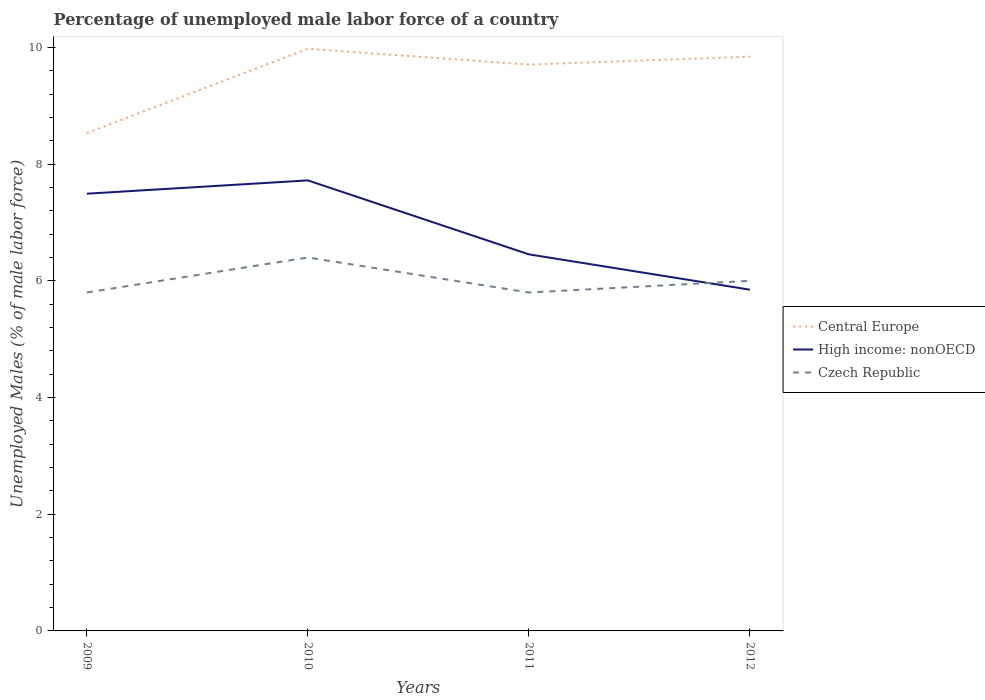Across all years, what is the maximum percentage of unemployed male labor force in Czech Republic?
Keep it short and to the point. 5.8. In which year was the percentage of unemployed male labor force in Czech Republic maximum?
Give a very brief answer. 2009. What is the total percentage of unemployed male labor force in Czech Republic in the graph?
Your answer should be compact. -0.2. What is the difference between the highest and the second highest percentage of unemployed male labor force in Czech Republic?
Provide a short and direct response. 0.6. What is the difference between the highest and the lowest percentage of unemployed male labor force in Central Europe?
Your response must be concise. 3. How many lines are there?
Your answer should be compact. 3. What is the difference between two consecutive major ticks on the Y-axis?
Your answer should be very brief. 2. Are the values on the major ticks of Y-axis written in scientific E-notation?
Ensure brevity in your answer.  No. Does the graph contain any zero values?
Ensure brevity in your answer.  No. What is the title of the graph?
Provide a short and direct response. Percentage of unemployed male labor force of a country. Does "Low income" appear as one of the legend labels in the graph?
Provide a short and direct response. No. What is the label or title of the X-axis?
Your answer should be compact. Years. What is the label or title of the Y-axis?
Provide a succinct answer. Unemployed Males (% of male labor force). What is the Unemployed Males (% of male labor force) in Central Europe in 2009?
Your answer should be compact. 8.53. What is the Unemployed Males (% of male labor force) of High income: nonOECD in 2009?
Your answer should be very brief. 7.49. What is the Unemployed Males (% of male labor force) of Czech Republic in 2009?
Offer a very short reply. 5.8. What is the Unemployed Males (% of male labor force) in Central Europe in 2010?
Your response must be concise. 9.98. What is the Unemployed Males (% of male labor force) in High income: nonOECD in 2010?
Make the answer very short. 7.72. What is the Unemployed Males (% of male labor force) of Czech Republic in 2010?
Offer a terse response. 6.4. What is the Unemployed Males (% of male labor force) of Central Europe in 2011?
Ensure brevity in your answer.  9.71. What is the Unemployed Males (% of male labor force) in High income: nonOECD in 2011?
Your response must be concise. 6.45. What is the Unemployed Males (% of male labor force) in Czech Republic in 2011?
Offer a terse response. 5.8. What is the Unemployed Males (% of male labor force) in Central Europe in 2012?
Offer a terse response. 9.84. What is the Unemployed Males (% of male labor force) of High income: nonOECD in 2012?
Give a very brief answer. 5.85. What is the Unemployed Males (% of male labor force) in Czech Republic in 2012?
Your answer should be very brief. 6. Across all years, what is the maximum Unemployed Males (% of male labor force) of Central Europe?
Keep it short and to the point. 9.98. Across all years, what is the maximum Unemployed Males (% of male labor force) of High income: nonOECD?
Your response must be concise. 7.72. Across all years, what is the maximum Unemployed Males (% of male labor force) of Czech Republic?
Ensure brevity in your answer.  6.4. Across all years, what is the minimum Unemployed Males (% of male labor force) of Central Europe?
Provide a short and direct response. 8.53. Across all years, what is the minimum Unemployed Males (% of male labor force) of High income: nonOECD?
Your answer should be compact. 5.85. Across all years, what is the minimum Unemployed Males (% of male labor force) of Czech Republic?
Provide a short and direct response. 5.8. What is the total Unemployed Males (% of male labor force) of Central Europe in the graph?
Keep it short and to the point. 38.06. What is the total Unemployed Males (% of male labor force) of High income: nonOECD in the graph?
Give a very brief answer. 27.52. What is the total Unemployed Males (% of male labor force) in Czech Republic in the graph?
Ensure brevity in your answer.  24. What is the difference between the Unemployed Males (% of male labor force) in Central Europe in 2009 and that in 2010?
Provide a short and direct response. -1.44. What is the difference between the Unemployed Males (% of male labor force) of High income: nonOECD in 2009 and that in 2010?
Give a very brief answer. -0.23. What is the difference between the Unemployed Males (% of male labor force) in Czech Republic in 2009 and that in 2010?
Your response must be concise. -0.6. What is the difference between the Unemployed Males (% of male labor force) of Central Europe in 2009 and that in 2011?
Offer a very short reply. -1.17. What is the difference between the Unemployed Males (% of male labor force) of High income: nonOECD in 2009 and that in 2011?
Your answer should be very brief. 1.04. What is the difference between the Unemployed Males (% of male labor force) in Czech Republic in 2009 and that in 2011?
Provide a succinct answer. 0. What is the difference between the Unemployed Males (% of male labor force) of Central Europe in 2009 and that in 2012?
Ensure brevity in your answer.  -1.31. What is the difference between the Unemployed Males (% of male labor force) of High income: nonOECD in 2009 and that in 2012?
Your response must be concise. 1.64. What is the difference between the Unemployed Males (% of male labor force) of Czech Republic in 2009 and that in 2012?
Keep it short and to the point. -0.2. What is the difference between the Unemployed Males (% of male labor force) of Central Europe in 2010 and that in 2011?
Offer a very short reply. 0.27. What is the difference between the Unemployed Males (% of male labor force) of High income: nonOECD in 2010 and that in 2011?
Give a very brief answer. 1.27. What is the difference between the Unemployed Males (% of male labor force) in Czech Republic in 2010 and that in 2011?
Offer a terse response. 0.6. What is the difference between the Unemployed Males (% of male labor force) in Central Europe in 2010 and that in 2012?
Keep it short and to the point. 0.14. What is the difference between the Unemployed Males (% of male labor force) in High income: nonOECD in 2010 and that in 2012?
Provide a succinct answer. 1.87. What is the difference between the Unemployed Males (% of male labor force) in Czech Republic in 2010 and that in 2012?
Provide a succinct answer. 0.4. What is the difference between the Unemployed Males (% of male labor force) of Central Europe in 2011 and that in 2012?
Give a very brief answer. -0.14. What is the difference between the Unemployed Males (% of male labor force) in High income: nonOECD in 2011 and that in 2012?
Your response must be concise. 0.61. What is the difference between the Unemployed Males (% of male labor force) of Czech Republic in 2011 and that in 2012?
Your response must be concise. -0.2. What is the difference between the Unemployed Males (% of male labor force) in Central Europe in 2009 and the Unemployed Males (% of male labor force) in High income: nonOECD in 2010?
Keep it short and to the point. 0.81. What is the difference between the Unemployed Males (% of male labor force) of Central Europe in 2009 and the Unemployed Males (% of male labor force) of Czech Republic in 2010?
Provide a short and direct response. 2.13. What is the difference between the Unemployed Males (% of male labor force) of High income: nonOECD in 2009 and the Unemployed Males (% of male labor force) of Czech Republic in 2010?
Provide a short and direct response. 1.09. What is the difference between the Unemployed Males (% of male labor force) of Central Europe in 2009 and the Unemployed Males (% of male labor force) of High income: nonOECD in 2011?
Give a very brief answer. 2.08. What is the difference between the Unemployed Males (% of male labor force) in Central Europe in 2009 and the Unemployed Males (% of male labor force) in Czech Republic in 2011?
Your answer should be very brief. 2.73. What is the difference between the Unemployed Males (% of male labor force) in High income: nonOECD in 2009 and the Unemployed Males (% of male labor force) in Czech Republic in 2011?
Make the answer very short. 1.69. What is the difference between the Unemployed Males (% of male labor force) in Central Europe in 2009 and the Unemployed Males (% of male labor force) in High income: nonOECD in 2012?
Offer a very short reply. 2.68. What is the difference between the Unemployed Males (% of male labor force) in Central Europe in 2009 and the Unemployed Males (% of male labor force) in Czech Republic in 2012?
Keep it short and to the point. 2.53. What is the difference between the Unemployed Males (% of male labor force) in High income: nonOECD in 2009 and the Unemployed Males (% of male labor force) in Czech Republic in 2012?
Offer a terse response. 1.49. What is the difference between the Unemployed Males (% of male labor force) of Central Europe in 2010 and the Unemployed Males (% of male labor force) of High income: nonOECD in 2011?
Ensure brevity in your answer.  3.52. What is the difference between the Unemployed Males (% of male labor force) of Central Europe in 2010 and the Unemployed Males (% of male labor force) of Czech Republic in 2011?
Ensure brevity in your answer.  4.18. What is the difference between the Unemployed Males (% of male labor force) in High income: nonOECD in 2010 and the Unemployed Males (% of male labor force) in Czech Republic in 2011?
Your answer should be compact. 1.92. What is the difference between the Unemployed Males (% of male labor force) of Central Europe in 2010 and the Unemployed Males (% of male labor force) of High income: nonOECD in 2012?
Provide a succinct answer. 4.13. What is the difference between the Unemployed Males (% of male labor force) in Central Europe in 2010 and the Unemployed Males (% of male labor force) in Czech Republic in 2012?
Provide a short and direct response. 3.98. What is the difference between the Unemployed Males (% of male labor force) of High income: nonOECD in 2010 and the Unemployed Males (% of male labor force) of Czech Republic in 2012?
Offer a very short reply. 1.72. What is the difference between the Unemployed Males (% of male labor force) in Central Europe in 2011 and the Unemployed Males (% of male labor force) in High income: nonOECD in 2012?
Provide a succinct answer. 3.86. What is the difference between the Unemployed Males (% of male labor force) of Central Europe in 2011 and the Unemployed Males (% of male labor force) of Czech Republic in 2012?
Give a very brief answer. 3.71. What is the difference between the Unemployed Males (% of male labor force) in High income: nonOECD in 2011 and the Unemployed Males (% of male labor force) in Czech Republic in 2012?
Offer a very short reply. 0.45. What is the average Unemployed Males (% of male labor force) of Central Europe per year?
Offer a very short reply. 9.51. What is the average Unemployed Males (% of male labor force) in High income: nonOECD per year?
Your answer should be compact. 6.88. In the year 2009, what is the difference between the Unemployed Males (% of male labor force) in Central Europe and Unemployed Males (% of male labor force) in High income: nonOECD?
Your response must be concise. 1.04. In the year 2009, what is the difference between the Unemployed Males (% of male labor force) of Central Europe and Unemployed Males (% of male labor force) of Czech Republic?
Provide a succinct answer. 2.73. In the year 2009, what is the difference between the Unemployed Males (% of male labor force) in High income: nonOECD and Unemployed Males (% of male labor force) in Czech Republic?
Your response must be concise. 1.69. In the year 2010, what is the difference between the Unemployed Males (% of male labor force) in Central Europe and Unemployed Males (% of male labor force) in High income: nonOECD?
Provide a succinct answer. 2.26. In the year 2010, what is the difference between the Unemployed Males (% of male labor force) of Central Europe and Unemployed Males (% of male labor force) of Czech Republic?
Give a very brief answer. 3.58. In the year 2010, what is the difference between the Unemployed Males (% of male labor force) of High income: nonOECD and Unemployed Males (% of male labor force) of Czech Republic?
Your answer should be very brief. 1.32. In the year 2011, what is the difference between the Unemployed Males (% of male labor force) in Central Europe and Unemployed Males (% of male labor force) in High income: nonOECD?
Make the answer very short. 3.25. In the year 2011, what is the difference between the Unemployed Males (% of male labor force) of Central Europe and Unemployed Males (% of male labor force) of Czech Republic?
Ensure brevity in your answer.  3.91. In the year 2011, what is the difference between the Unemployed Males (% of male labor force) in High income: nonOECD and Unemployed Males (% of male labor force) in Czech Republic?
Ensure brevity in your answer.  0.65. In the year 2012, what is the difference between the Unemployed Males (% of male labor force) in Central Europe and Unemployed Males (% of male labor force) in High income: nonOECD?
Offer a very short reply. 3.99. In the year 2012, what is the difference between the Unemployed Males (% of male labor force) of Central Europe and Unemployed Males (% of male labor force) of Czech Republic?
Ensure brevity in your answer.  3.84. In the year 2012, what is the difference between the Unemployed Males (% of male labor force) in High income: nonOECD and Unemployed Males (% of male labor force) in Czech Republic?
Your answer should be compact. -0.15. What is the ratio of the Unemployed Males (% of male labor force) of Central Europe in 2009 to that in 2010?
Your answer should be very brief. 0.86. What is the ratio of the Unemployed Males (% of male labor force) in High income: nonOECD in 2009 to that in 2010?
Your response must be concise. 0.97. What is the ratio of the Unemployed Males (% of male labor force) of Czech Republic in 2009 to that in 2010?
Provide a short and direct response. 0.91. What is the ratio of the Unemployed Males (% of male labor force) in Central Europe in 2009 to that in 2011?
Your answer should be very brief. 0.88. What is the ratio of the Unemployed Males (% of male labor force) of High income: nonOECD in 2009 to that in 2011?
Provide a short and direct response. 1.16. What is the ratio of the Unemployed Males (% of male labor force) in Central Europe in 2009 to that in 2012?
Your answer should be very brief. 0.87. What is the ratio of the Unemployed Males (% of male labor force) in High income: nonOECD in 2009 to that in 2012?
Give a very brief answer. 1.28. What is the ratio of the Unemployed Males (% of male labor force) of Czech Republic in 2009 to that in 2012?
Provide a short and direct response. 0.97. What is the ratio of the Unemployed Males (% of male labor force) of Central Europe in 2010 to that in 2011?
Offer a terse response. 1.03. What is the ratio of the Unemployed Males (% of male labor force) of High income: nonOECD in 2010 to that in 2011?
Give a very brief answer. 1.2. What is the ratio of the Unemployed Males (% of male labor force) in Czech Republic in 2010 to that in 2011?
Provide a succinct answer. 1.1. What is the ratio of the Unemployed Males (% of male labor force) of Central Europe in 2010 to that in 2012?
Ensure brevity in your answer.  1.01. What is the ratio of the Unemployed Males (% of male labor force) of High income: nonOECD in 2010 to that in 2012?
Ensure brevity in your answer.  1.32. What is the ratio of the Unemployed Males (% of male labor force) in Czech Republic in 2010 to that in 2012?
Your answer should be very brief. 1.07. What is the ratio of the Unemployed Males (% of male labor force) of Central Europe in 2011 to that in 2012?
Your answer should be very brief. 0.99. What is the ratio of the Unemployed Males (% of male labor force) of High income: nonOECD in 2011 to that in 2012?
Ensure brevity in your answer.  1.1. What is the ratio of the Unemployed Males (% of male labor force) of Czech Republic in 2011 to that in 2012?
Provide a short and direct response. 0.97. What is the difference between the highest and the second highest Unemployed Males (% of male labor force) in Central Europe?
Provide a short and direct response. 0.14. What is the difference between the highest and the second highest Unemployed Males (% of male labor force) in High income: nonOECD?
Provide a short and direct response. 0.23. What is the difference between the highest and the second highest Unemployed Males (% of male labor force) in Czech Republic?
Your response must be concise. 0.4. What is the difference between the highest and the lowest Unemployed Males (% of male labor force) of Central Europe?
Ensure brevity in your answer.  1.44. What is the difference between the highest and the lowest Unemployed Males (% of male labor force) in High income: nonOECD?
Your answer should be compact. 1.87. What is the difference between the highest and the lowest Unemployed Males (% of male labor force) in Czech Republic?
Make the answer very short. 0.6. 